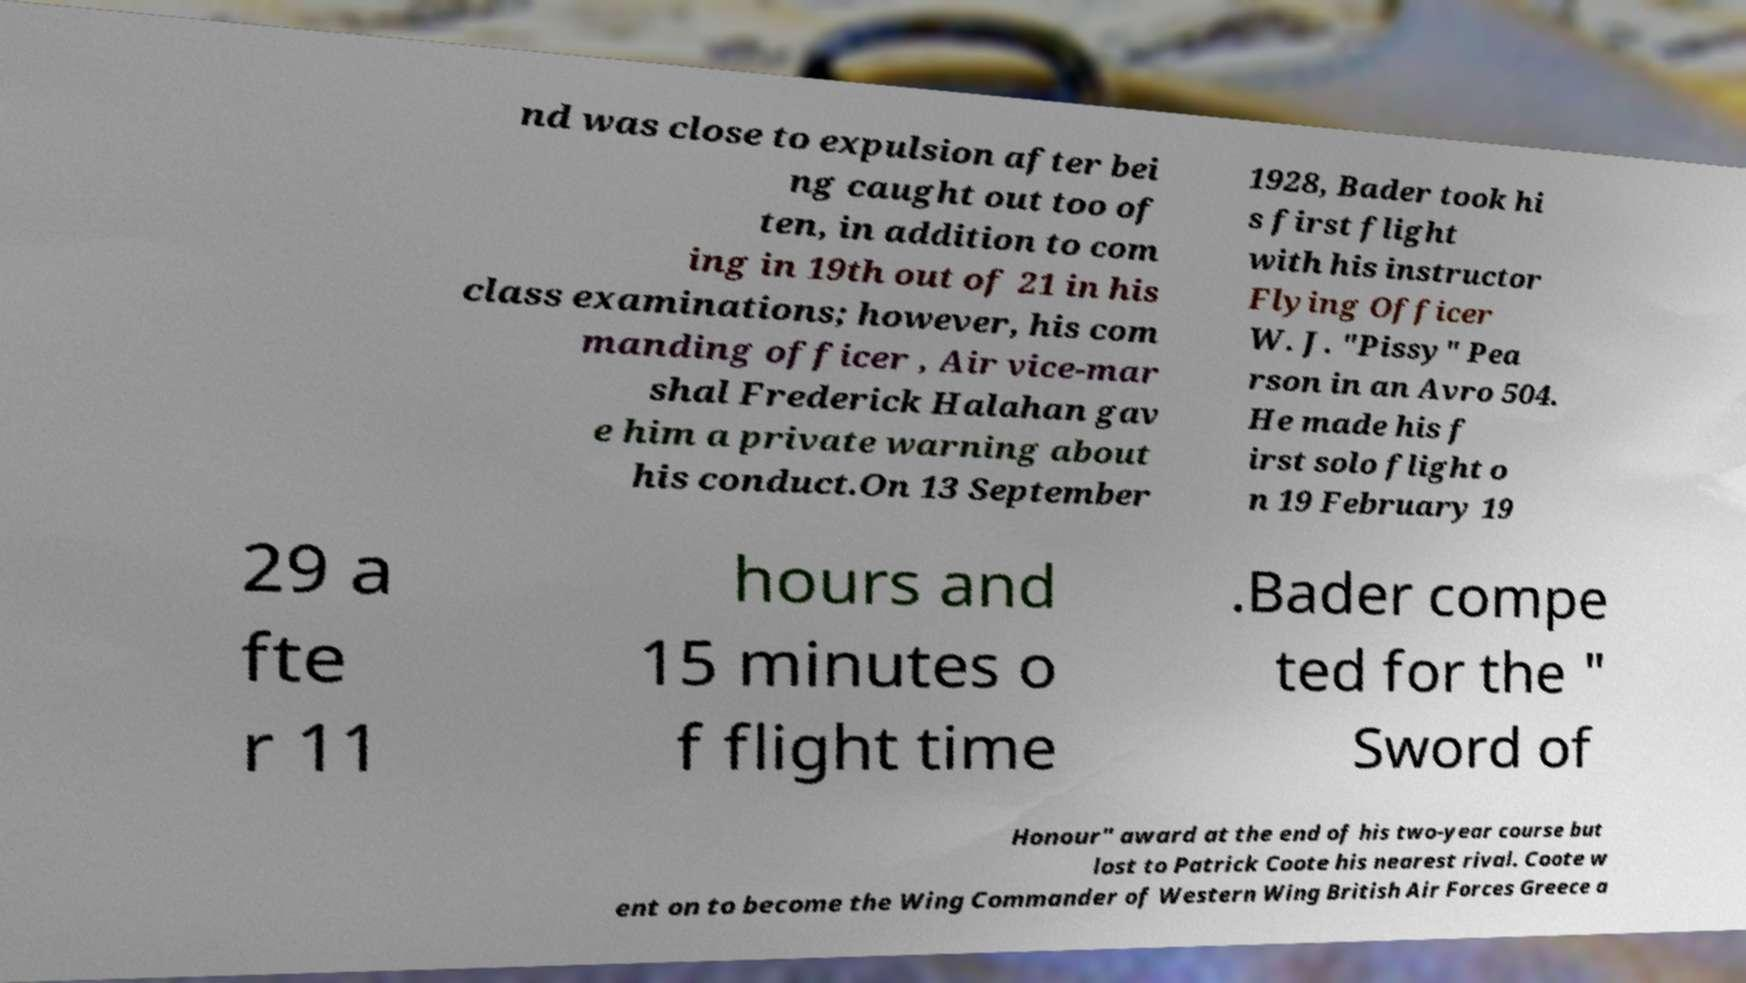Can you accurately transcribe the text from the provided image for me? nd was close to expulsion after bei ng caught out too of ten, in addition to com ing in 19th out of 21 in his class examinations; however, his com manding officer , Air vice-mar shal Frederick Halahan gav e him a private warning about his conduct.On 13 September 1928, Bader took hi s first flight with his instructor Flying Officer W. J. "Pissy" Pea rson in an Avro 504. He made his f irst solo flight o n 19 February 19 29 a fte r 11 hours and 15 minutes o f flight time .Bader compe ted for the " Sword of Honour" award at the end of his two-year course but lost to Patrick Coote his nearest rival. Coote w ent on to become the Wing Commander of Western Wing British Air Forces Greece a 